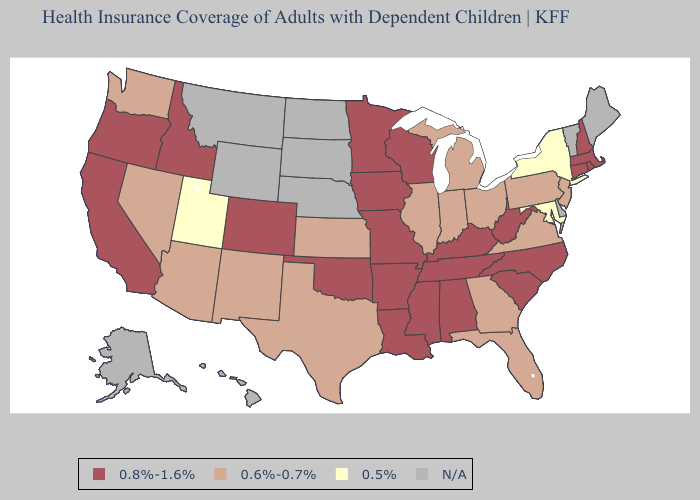What is the lowest value in the Northeast?
Short answer required. 0.5%. What is the value of Missouri?
Keep it brief. 0.8%-1.6%. What is the highest value in the South ?
Give a very brief answer. 0.8%-1.6%. What is the value of West Virginia?
Concise answer only. 0.8%-1.6%. Name the states that have a value in the range 0.8%-1.6%?
Give a very brief answer. Alabama, Arkansas, California, Colorado, Connecticut, Idaho, Iowa, Kentucky, Louisiana, Massachusetts, Minnesota, Mississippi, Missouri, New Hampshire, North Carolina, Oklahoma, Oregon, Rhode Island, South Carolina, Tennessee, West Virginia, Wisconsin. What is the lowest value in the Northeast?
Be succinct. 0.5%. Does New Jersey have the highest value in the Northeast?
Concise answer only. No. What is the value of West Virginia?
Write a very short answer. 0.8%-1.6%. Among the states that border Oklahoma , which have the highest value?
Answer briefly. Arkansas, Colorado, Missouri. Among the states that border Massachusetts , which have the lowest value?
Give a very brief answer. New York. Name the states that have a value in the range 0.5%?
Quick response, please. Maryland, New York, Utah. What is the highest value in states that border Illinois?
Keep it brief. 0.8%-1.6%. 